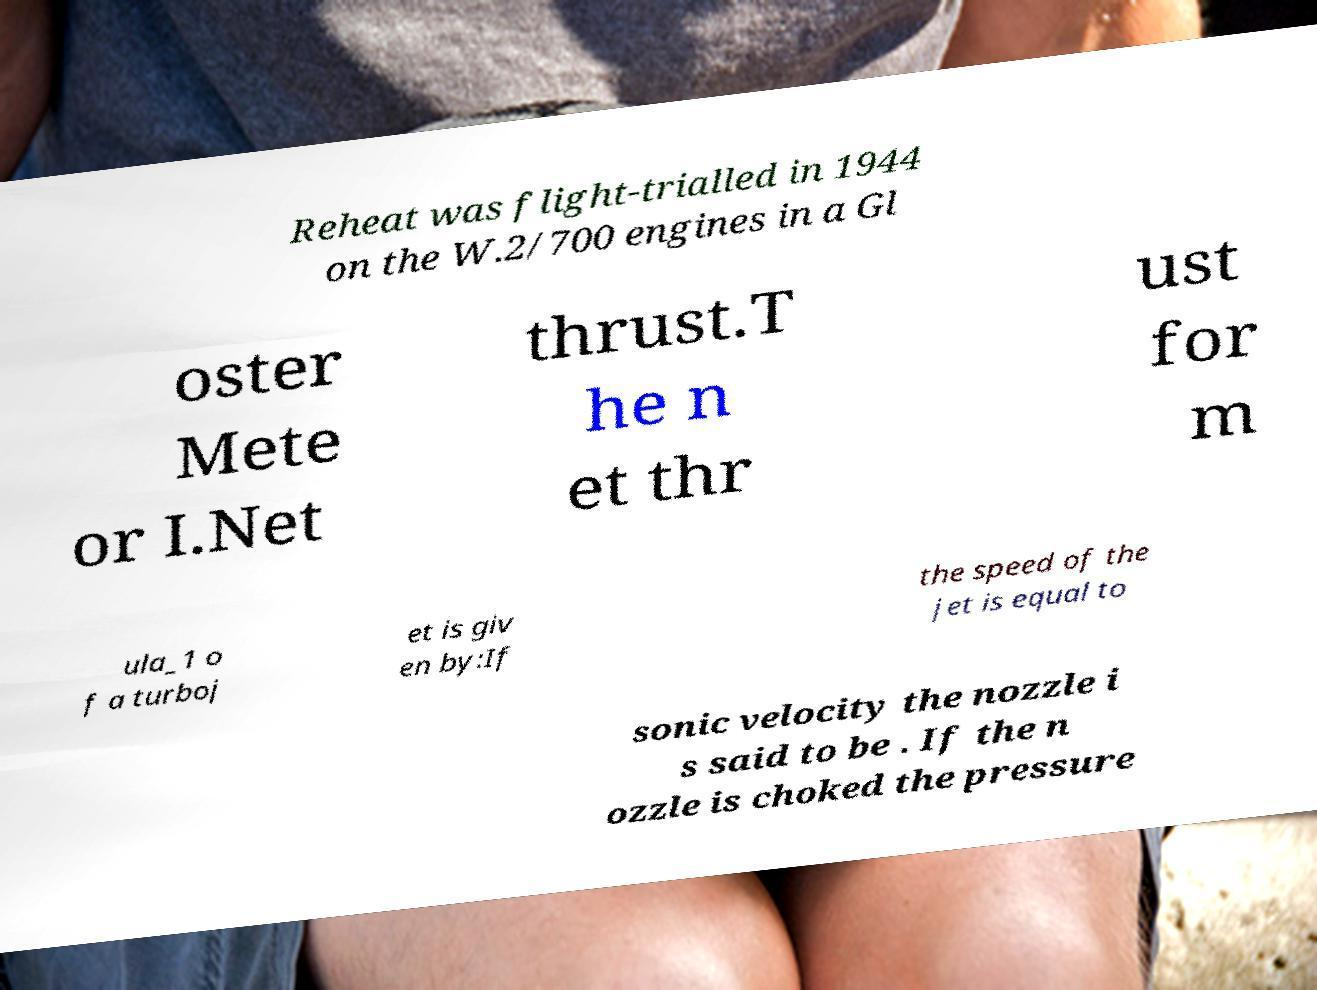Can you accurately transcribe the text from the provided image for me? Reheat was flight-trialled in 1944 on the W.2/700 engines in a Gl oster Mete or I.Net thrust.T he n et thr ust for m ula_1 o f a turboj et is giv en by:If the speed of the jet is equal to sonic velocity the nozzle i s said to be . If the n ozzle is choked the pressure 